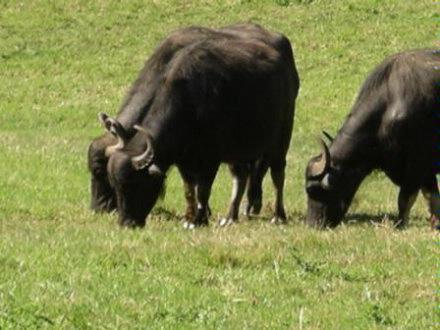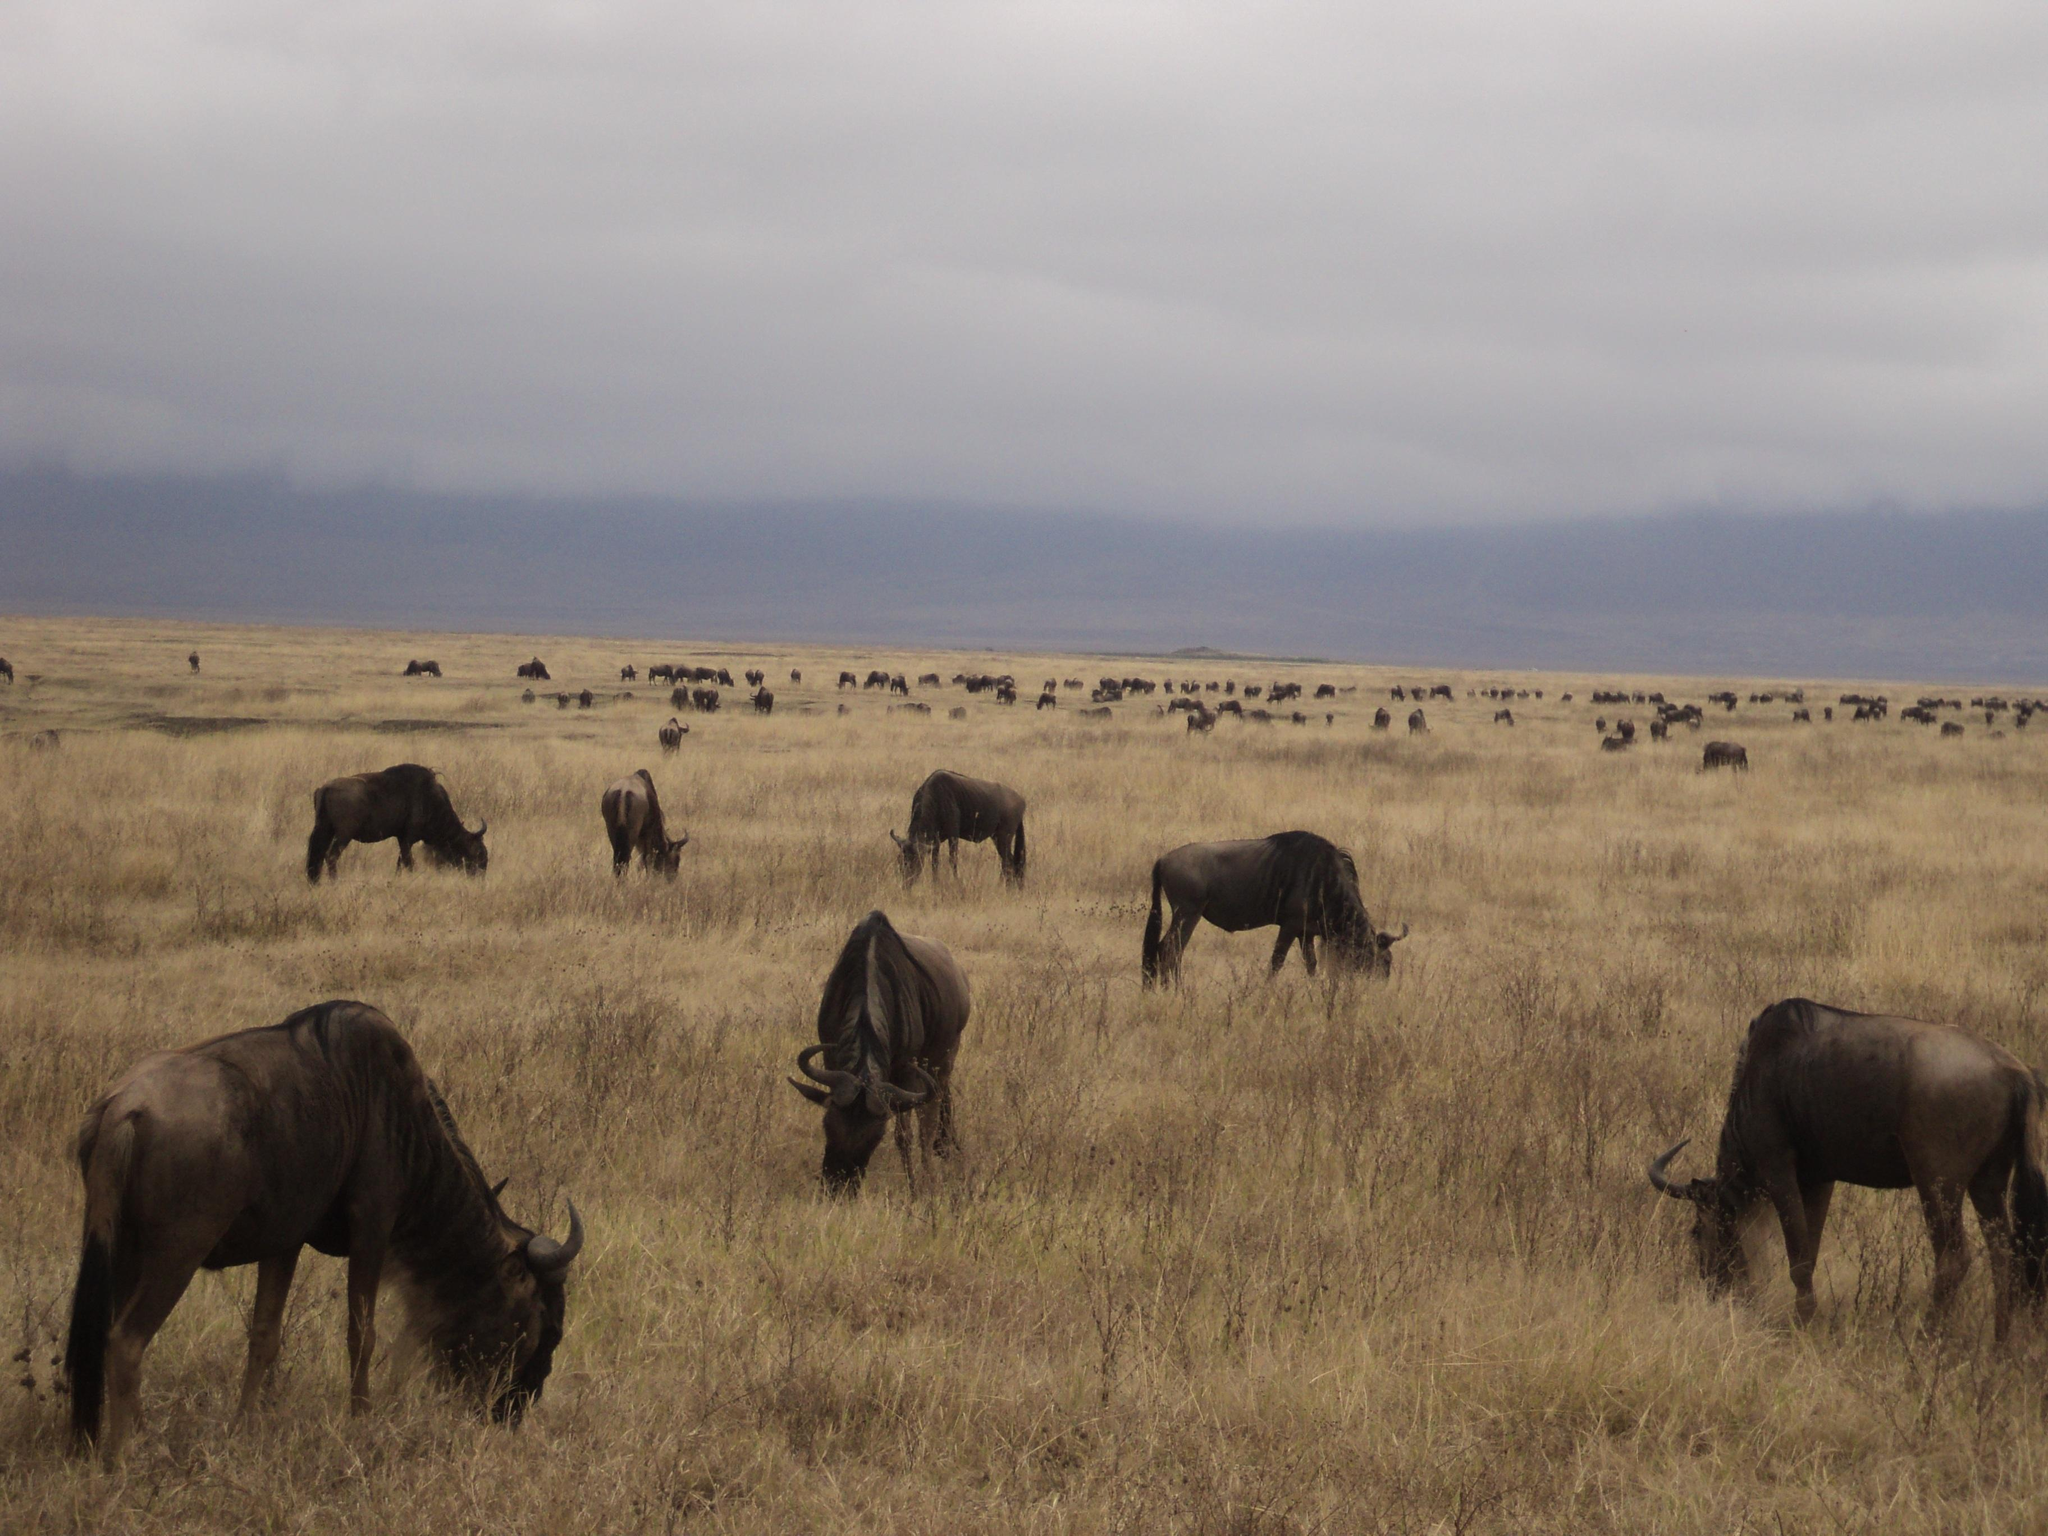The first image is the image on the left, the second image is the image on the right. Examine the images to the left and right. Is the description "Several buffalo are standing in front of channels of water in a green field in one image." accurate? Answer yes or no. No. The first image is the image on the left, the second image is the image on the right. Analyze the images presented: Is the assertion "In at least one image there are three bulls turned left grazing." valid? Answer yes or no. Yes. 